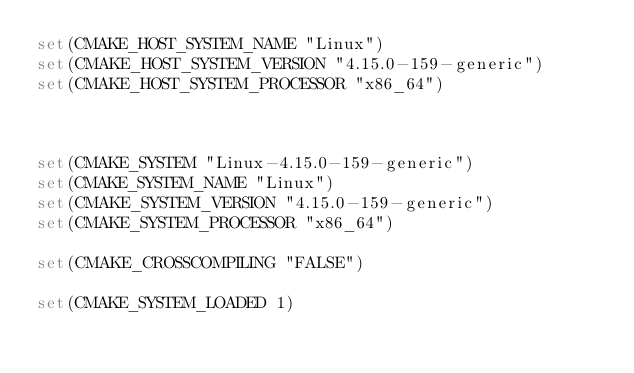Convert code to text. <code><loc_0><loc_0><loc_500><loc_500><_CMake_>set(CMAKE_HOST_SYSTEM_NAME "Linux")
set(CMAKE_HOST_SYSTEM_VERSION "4.15.0-159-generic")
set(CMAKE_HOST_SYSTEM_PROCESSOR "x86_64")



set(CMAKE_SYSTEM "Linux-4.15.0-159-generic")
set(CMAKE_SYSTEM_NAME "Linux")
set(CMAKE_SYSTEM_VERSION "4.15.0-159-generic")
set(CMAKE_SYSTEM_PROCESSOR "x86_64")

set(CMAKE_CROSSCOMPILING "FALSE")

set(CMAKE_SYSTEM_LOADED 1)
</code> 